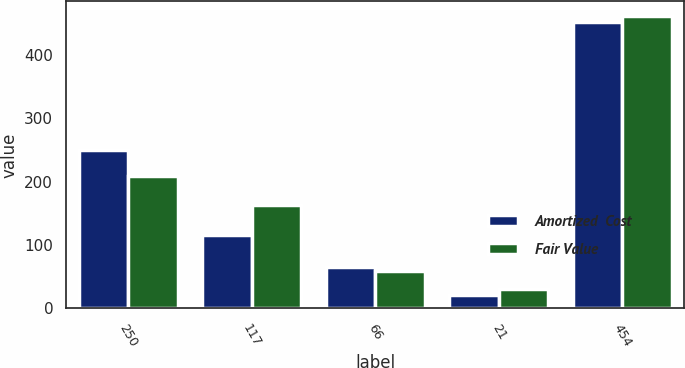<chart> <loc_0><loc_0><loc_500><loc_500><stacked_bar_chart><ecel><fcel>250<fcel>117<fcel>66<fcel>21<fcel>454<nl><fcel>Amortized  Cost<fcel>250<fcel>116<fcel>65<fcel>21<fcel>452<nl><fcel>Fair Value<fcel>209<fcel>164<fcel>59<fcel>30<fcel>462<nl></chart> 